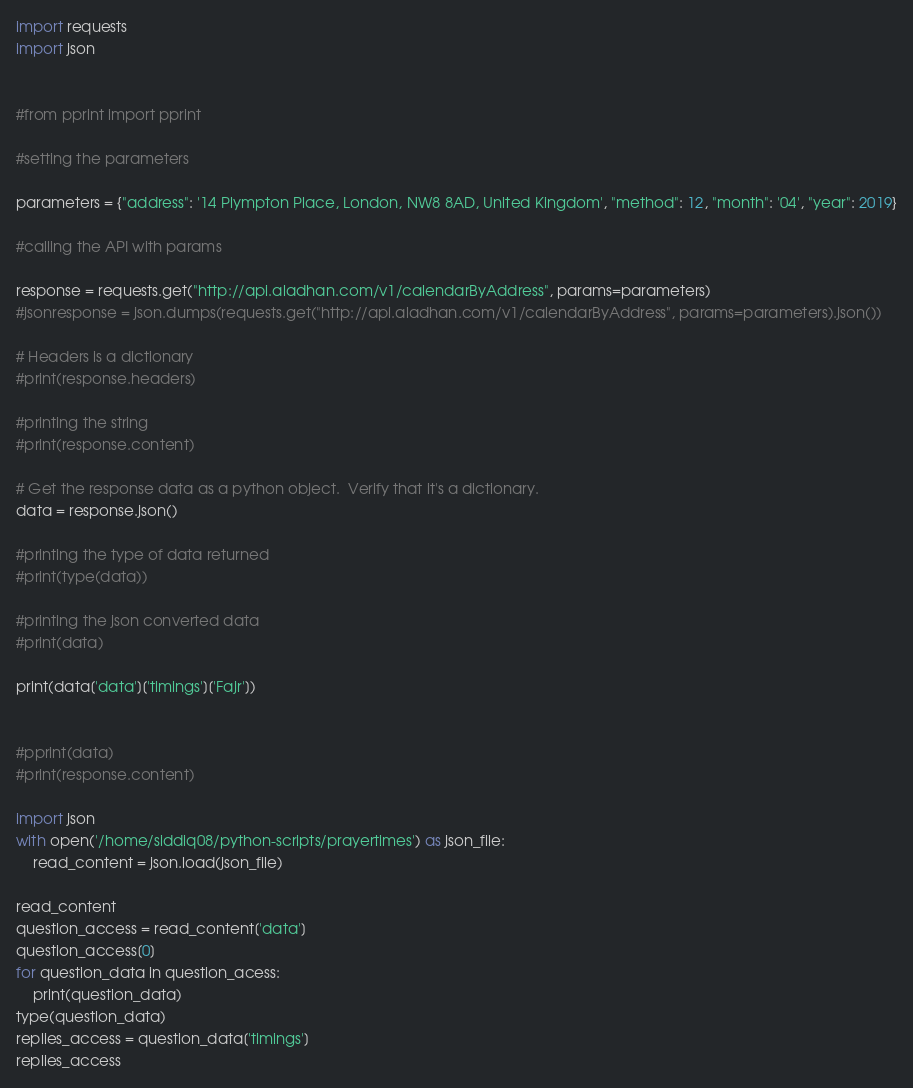Convert code to text. <code><loc_0><loc_0><loc_500><loc_500><_Python_>import requests
import json


#from pprint import pprint

#setting the parameters

parameters = {"address": '14 Plympton Place, London, NW8 8AD, United Kingdom', "method": 12, "month": '04', "year": 2019}

#calling the API with params

response = requests.get("http://api.aladhan.com/v1/calendarByAddress", params=parameters)
#jsonresponse = json.dumps(requests.get("http://api.aladhan.com/v1/calendarByAddress", params=parameters).json())

# Headers is a dictionary
#print(response.headers)

#printing the string
#print(response.content)

# Get the response data as a python object.  Verify that it's a dictionary.
data = response.json()

#printing the type of data returned
#print(type(data))

#printing the json converted data
#print(data)

print(data['data']['timings']['Fajr'])


#pprint(data)
#print(response.content)

import json
with open('/home/siddiq08/python-scripts/prayertimes') as json_file:
    read_content = json.load(json_file)

read_content
question_access = read_content['data']
question_access[0]
for question_data in question_acess:
    print(question_data)
type(question_data)
replies_access = question_data['timings']
replies_access
</code> 